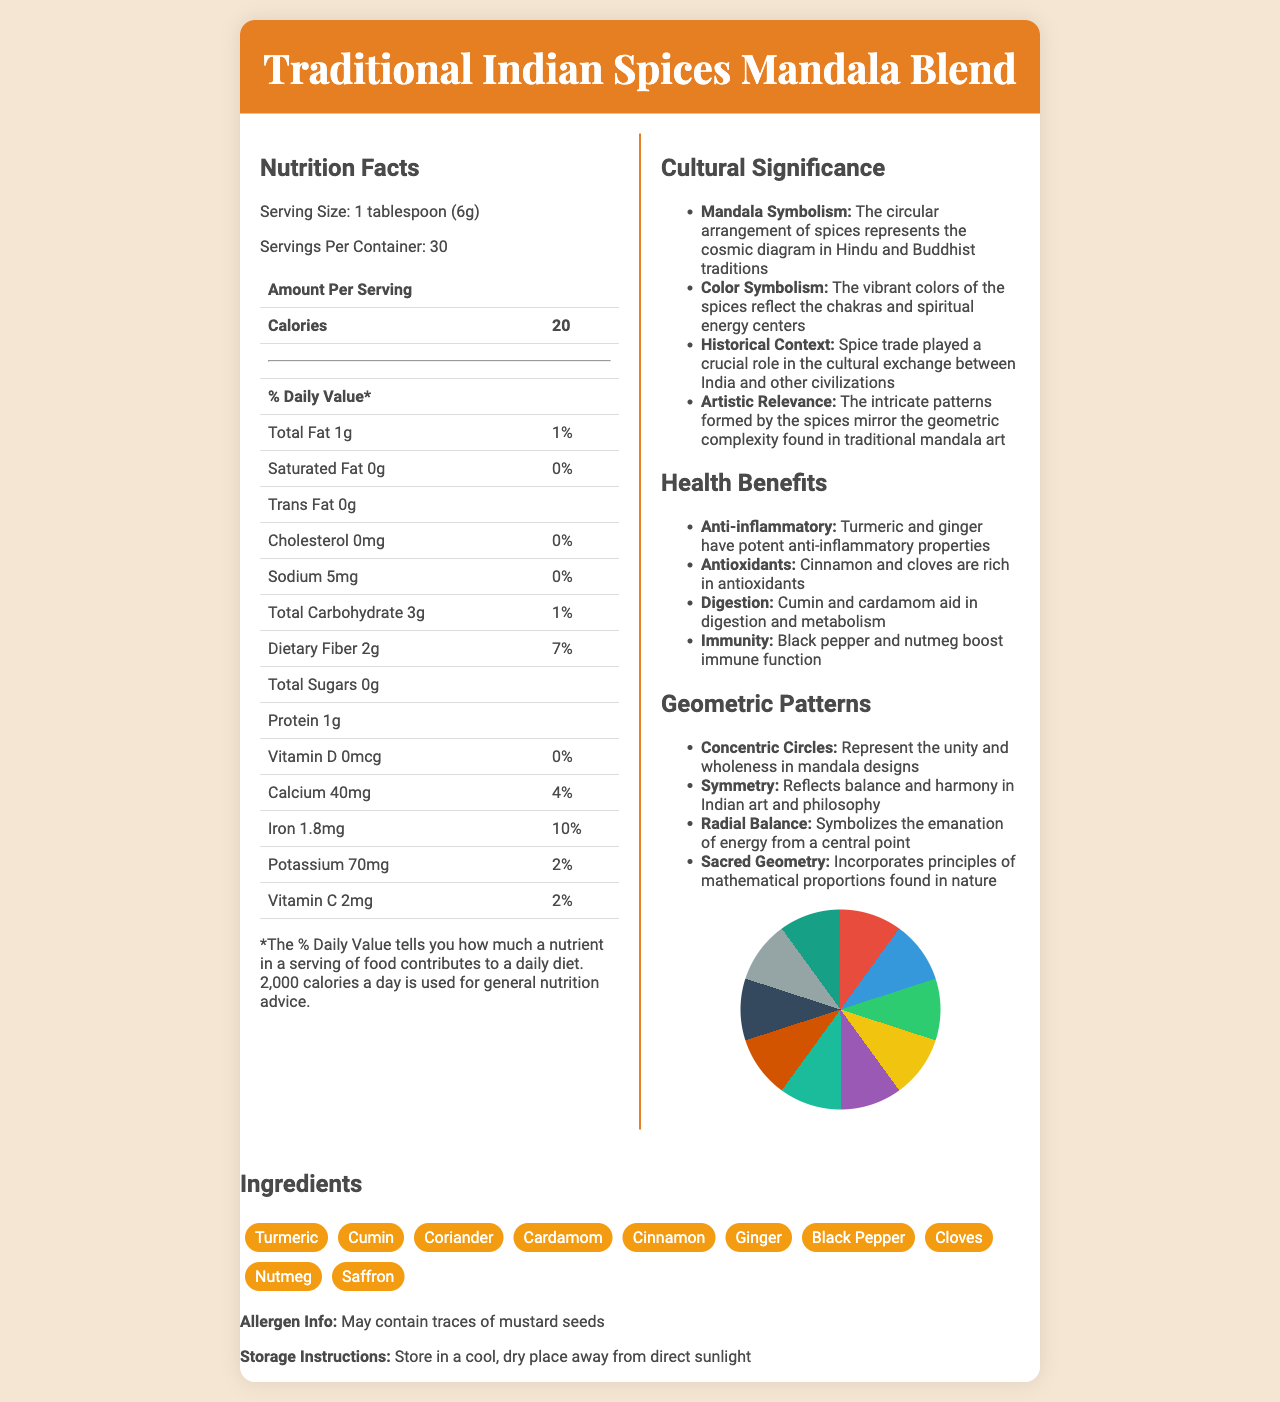What is the serving size of the Traditional Indian Spices Mandala Blend? The serving size is clearly mentioned in the nutrition facts as "1 tablespoon (6g)".
Answer: 1 tablespoon (6g) How many calories are there per serving? The nutrition facts state that there are 20 calories per serving.
Answer: 20 What are the two spices listed that have significant anti-inflammatory properties? The health benefits section mentions that Turmeric and Ginger have potent anti-inflammatory properties.
Answer: Turmeric and Ginger How much dietary fiber is in one serving? According to the nutrition facts, the dietary fiber per serving is 2g.
Answer: 2g Name two cultural significances of the circular arrangement of spices in the mandala blend. Mandala Symbolism and Color Symbolism are two cultural significances mentioned under cultural significance.
Answer: Mandala Symbolism and Color Symbolism Which vitamin is not present in any amount in the spice blend? A. Vitamin D B. Vitamin C C. Vitamin B12 D. Vitamin E The nutrition facts indicate that Vitamin D has an amount of 0mcg and a daily value of 0%.
Answer: A. Vitamin D Which two ingredients in the blend are associated with aiding digestion and metabolism? A. Cinnamon and Saffron B. Cumin and Cardamom C. Turmeric and Nutmeg D. Cloves and Black Pepper The health benefits section states that Cumin and Cardamom aid in digestion and metabolism.
Answer: B. Cumin and Cardamom Is the Traditional Indian Spices Mandala Blend a significant source of protein? The blend contains 1g of protein, which is not significant.
Answer: No Summarize the main idea of the document. The document covers various aspects such as nutritional content, cultural background, health-related information, and artistic relevance, presenting a comprehensive overview of the spice blend's significance and utility.
Answer: The document provides detailed information about the Traditional Indian Spices Mandala Blend, including its nutrition facts, cultural significance, health benefits, geometric patterns in mandala art, and storage instructions. What is the historical context mentioned in the document regarding the spice blend? The historical context described under cultural significance is about the spice trade facilitating cultural exchange.
Answer: Spice trade played a crucial role in the cultural exchange between India and other civilizations How many servings are there per container of the spice blend? The nutrition facts state that there are 30 servings per container.
Answer: 30 What is the % daily value of iron in one serving? The % daily value for iron is explicitly stated as 10% in the nutrition facts.
Answer: 10% What geometric pattern symbolizes the unity and wholeness in mandala designs? The geometric patterns section indicates that concentric circles represent unity and wholeness.
Answer: Concentric Circles Does the table in the nutrition facts section include the amount of Vitamin B12? The table only lists Vitamin D, Calcium, Iron, Potassium, and Vitamin C.
Answer: No How should the Traditional Indian Spices Mandala Blend be stored? The storage instructions specify storing the blend in a cool, dry place away from direct sunlight.
Answer: Store in a cool, dry place away from direct sunlight 